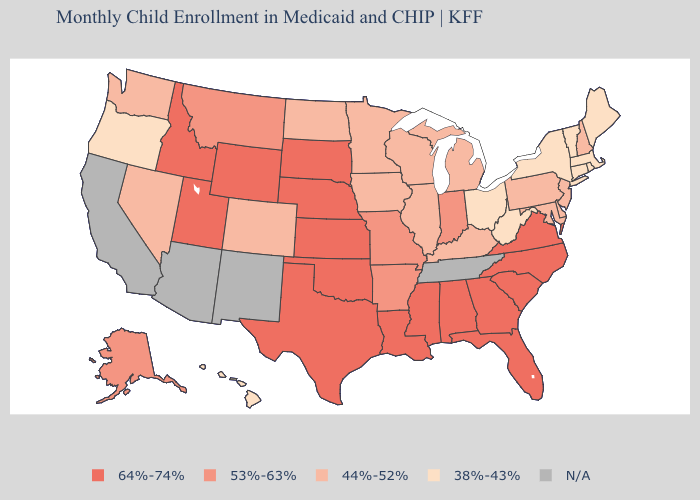Among the states that border New Mexico , does Colorado have the lowest value?
Be succinct. Yes. What is the value of North Dakota?
Short answer required. 44%-52%. Does Missouri have the lowest value in the MidWest?
Answer briefly. No. Is the legend a continuous bar?
Keep it brief. No. Among the states that border Illinois , which have the lowest value?
Quick response, please. Iowa, Kentucky, Wisconsin. Name the states that have a value in the range 38%-43%?
Write a very short answer. Connecticut, Hawaii, Maine, Massachusetts, New York, Ohio, Oregon, Rhode Island, Vermont, West Virginia. What is the value of Ohio?
Quick response, please. 38%-43%. Which states have the highest value in the USA?
Short answer required. Alabama, Florida, Georgia, Idaho, Kansas, Louisiana, Mississippi, Nebraska, North Carolina, Oklahoma, South Carolina, South Dakota, Texas, Utah, Virginia, Wyoming. What is the value of Connecticut?
Short answer required. 38%-43%. Name the states that have a value in the range 53%-63%?
Concise answer only. Alaska, Arkansas, Indiana, Missouri, Montana. Name the states that have a value in the range 38%-43%?
Keep it brief. Connecticut, Hawaii, Maine, Massachusetts, New York, Ohio, Oregon, Rhode Island, Vermont, West Virginia. What is the value of Tennessee?
Write a very short answer. N/A. What is the value of Kentucky?
Keep it brief. 44%-52%. 